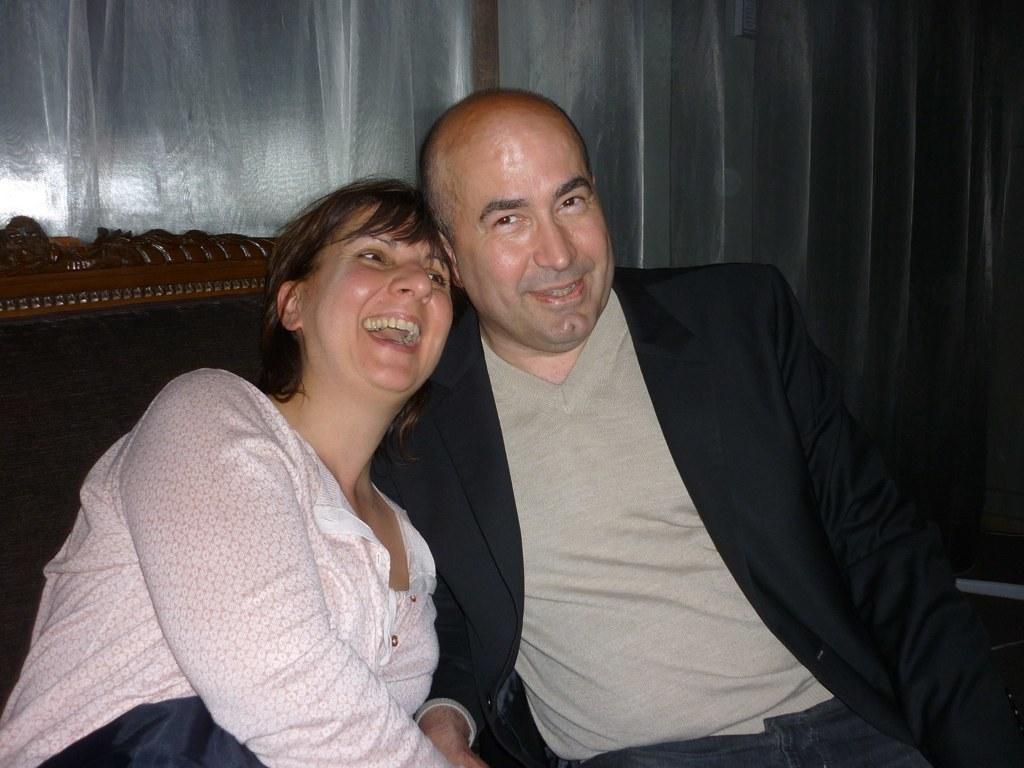How would you summarize this image in a sentence or two? In the picture we can see a man and a woman sitting in the chair and man is smiling and the woman is laughing and behind the chair we can see a curtain which is white in color. 